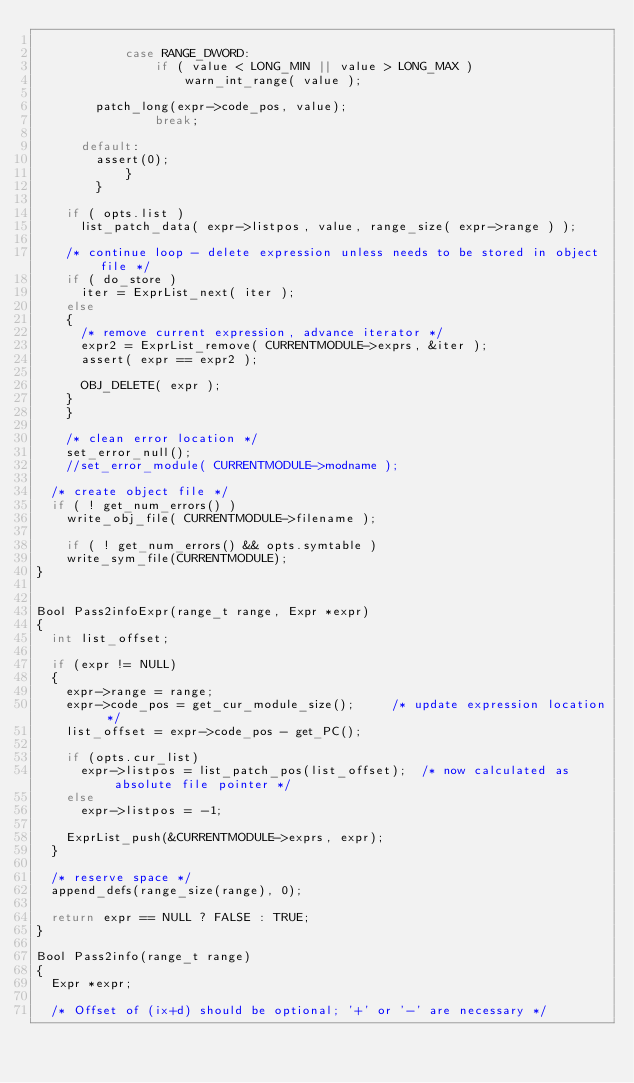<code> <loc_0><loc_0><loc_500><loc_500><_C_>
            case RANGE_DWORD:
                if ( value < LONG_MIN || value > LONG_MAX )
                    warn_int_range( value );

				patch_long(expr->code_pos, value);
                break;

			default:
				assert(0);
            }
        }

		if ( opts.list )
			list_patch_data( expr->listpos, value, range_size( expr->range ) );
			
		/* continue loop - delete expression unless needs to be stored in object file */
		if ( do_store )
			iter = ExprList_next( iter );
		else
		{
			/* remove current expression, advance iterator */
			expr2 = ExprList_remove( CURRENTMODULE->exprs, &iter );
			assert( expr == expr2 );

			OBJ_DELETE( expr );	
		}
    }

    /* clean error location */
    set_error_null();
    //set_error_module( CURRENTMODULE->modname );

	/* create object file */
	if ( ! get_num_errors() )
		write_obj_file( CURRENTMODULE->filename );

    if ( ! get_num_errors() && opts.symtable )
		write_sym_file(CURRENTMODULE);
}


Bool Pass2infoExpr(range_t range, Expr *expr)
{
	int list_offset;

	if (expr != NULL)
	{
		expr->range = range;
		expr->code_pos = get_cur_module_size();			/* update expression location */
		list_offset = expr->code_pos - get_PC();

		if (opts.cur_list)
			expr->listpos = list_patch_pos(list_offset);	/* now calculated as absolute file pointer */
		else
			expr->listpos = -1;

		ExprList_push(&CURRENTMODULE->exprs, expr);
	}

	/* reserve space */
	append_defs(range_size(range), 0);

	return expr == NULL ? FALSE : TRUE;
}

Bool Pass2info(range_t range)
{
	Expr *expr;
	
	/* Offset of (ix+d) should be optional; '+' or '-' are necessary */</code> 